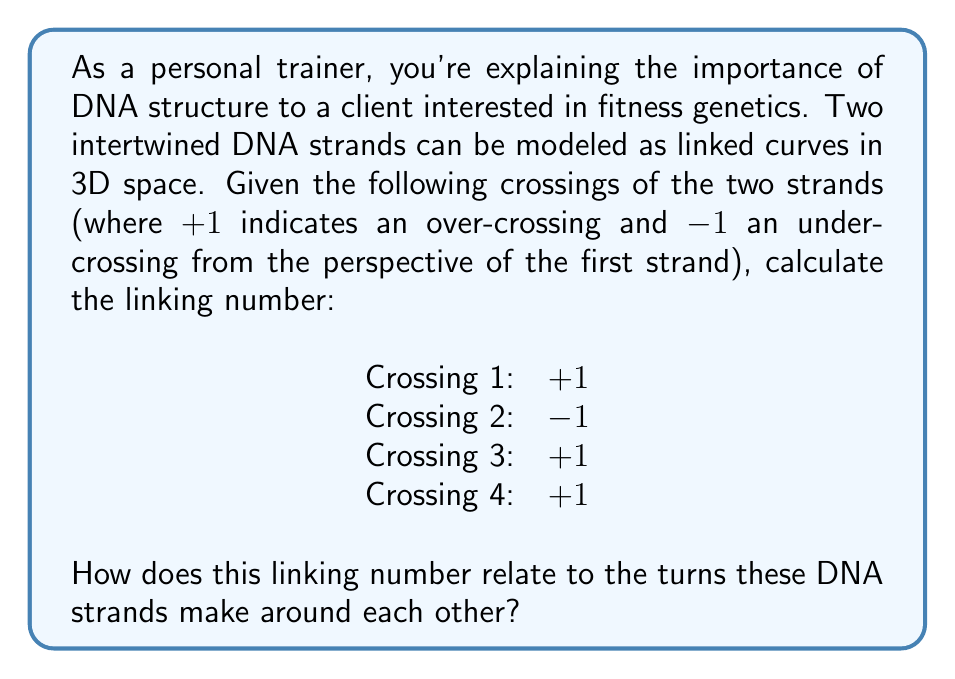Could you help me with this problem? To calculate the linking number between two intertwined DNA strands, we follow these steps:

1) The linking number is defined as half the sum of the signed crossings:

   $$ Lk = \frac{1}{2} \sum_{i} \epsilon_i $$

   where $\epsilon_i$ is the sign of each crossing (+1 or -1).

2) Sum up the given crossings:
   $$ \sum_{i} \epsilon_i = (+1) + (-1) + (+1) + (+1) = +2 $$

3) Calculate the linking number:
   $$ Lk = \frac{1}{2} \cdot (+2) = +1 $$

4) Interpret the result:
   A linking number of +1 indicates that the two DNA strands make one complete right-handed turn around each other. In the context of DNA, this corresponds to about 10.5 base pairs in B-form DNA, which is the most common form in living organisms.

5) Fitness relevance:
   Understanding DNA structure is crucial in genetics and can provide insights into how certain genes might affect athletic performance or response to different types of training.
Answer: $Lk = +1$, indicating one complete right-handed turn 